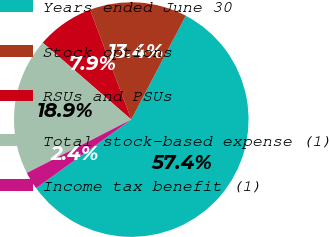<chart> <loc_0><loc_0><loc_500><loc_500><pie_chart><fcel>Years ended June 30<fcel>Stock options<fcel>RSUs and PSUs<fcel>Total stock-based expense (1)<fcel>Income tax benefit (1)<nl><fcel>57.36%<fcel>13.41%<fcel>7.91%<fcel>18.9%<fcel>2.42%<nl></chart> 